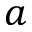<formula> <loc_0><loc_0><loc_500><loc_500>a</formula> 